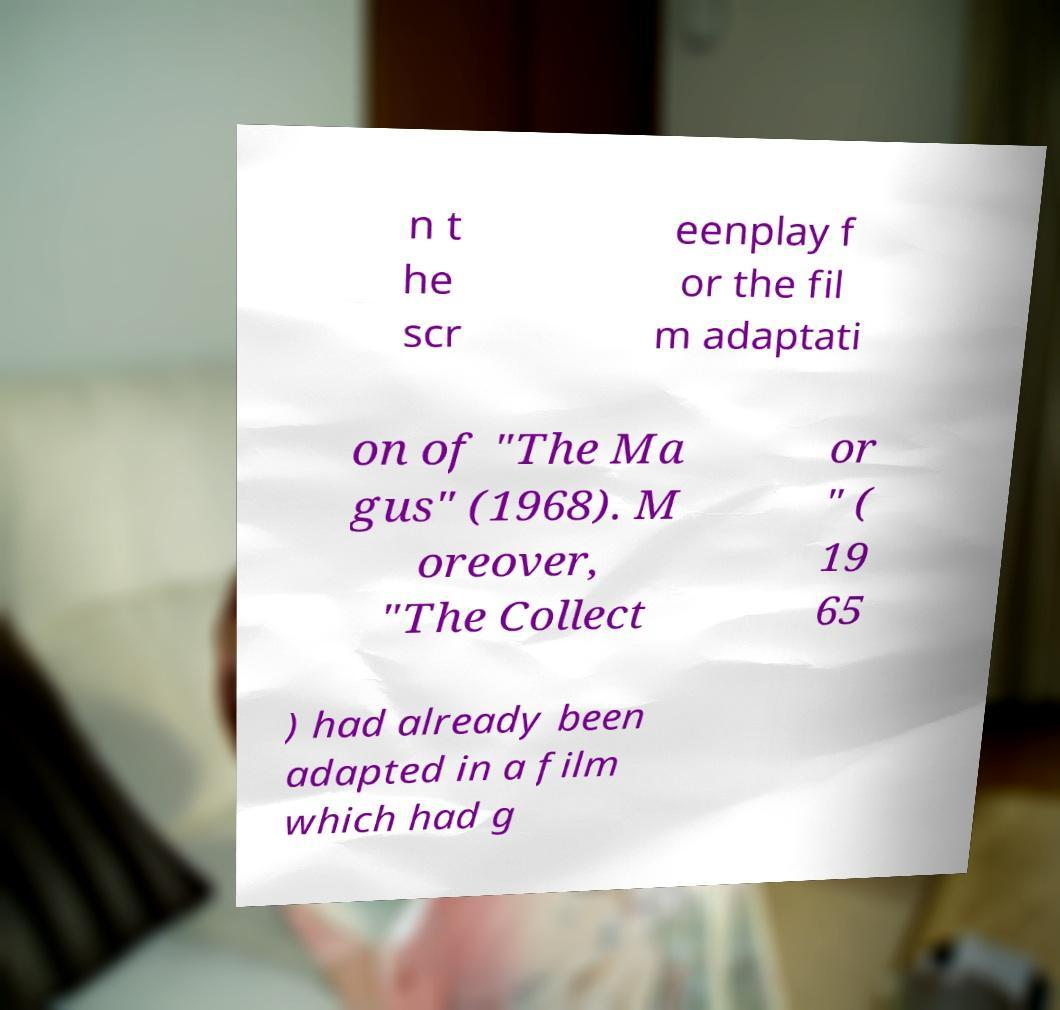What messages or text are displayed in this image? I need them in a readable, typed format. n t he scr eenplay f or the fil m adaptati on of "The Ma gus" (1968). M oreover, "The Collect or " ( 19 65 ) had already been adapted in a film which had g 